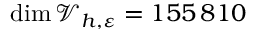Convert formula to latex. <formula><loc_0><loc_0><loc_500><loc_500>\dim \mathcal { V } _ { h , \varepsilon } = 1 5 5 { \, } 8 1 0</formula> 